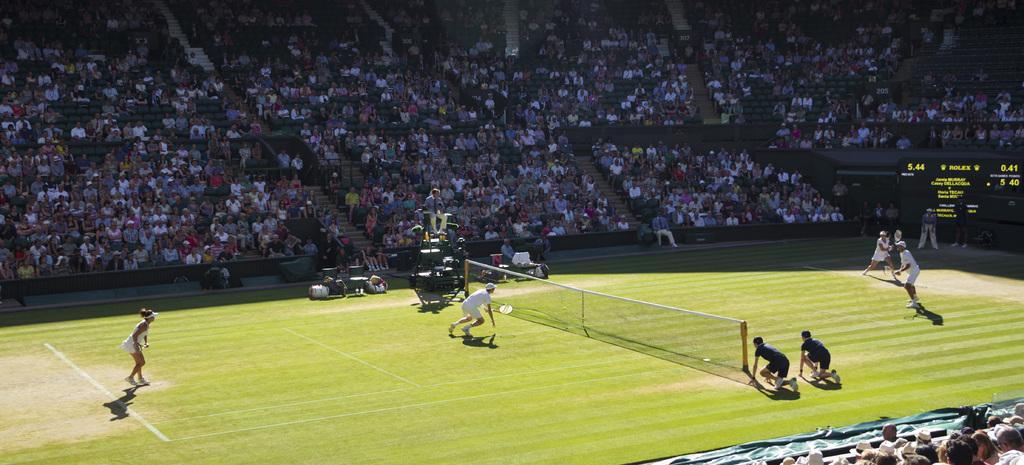What is the primary setting of the image? There is a ground in the image. What activity are the people engaged in on the ground? The people are standing around a net on the ground. Where are some other people located in the image? There are people sitting on chairs on a staircase in the image. What type of cherries can be seen hanging from the net in the image? There are no cherries present in the image; the net is likely being used for a sport or game. 